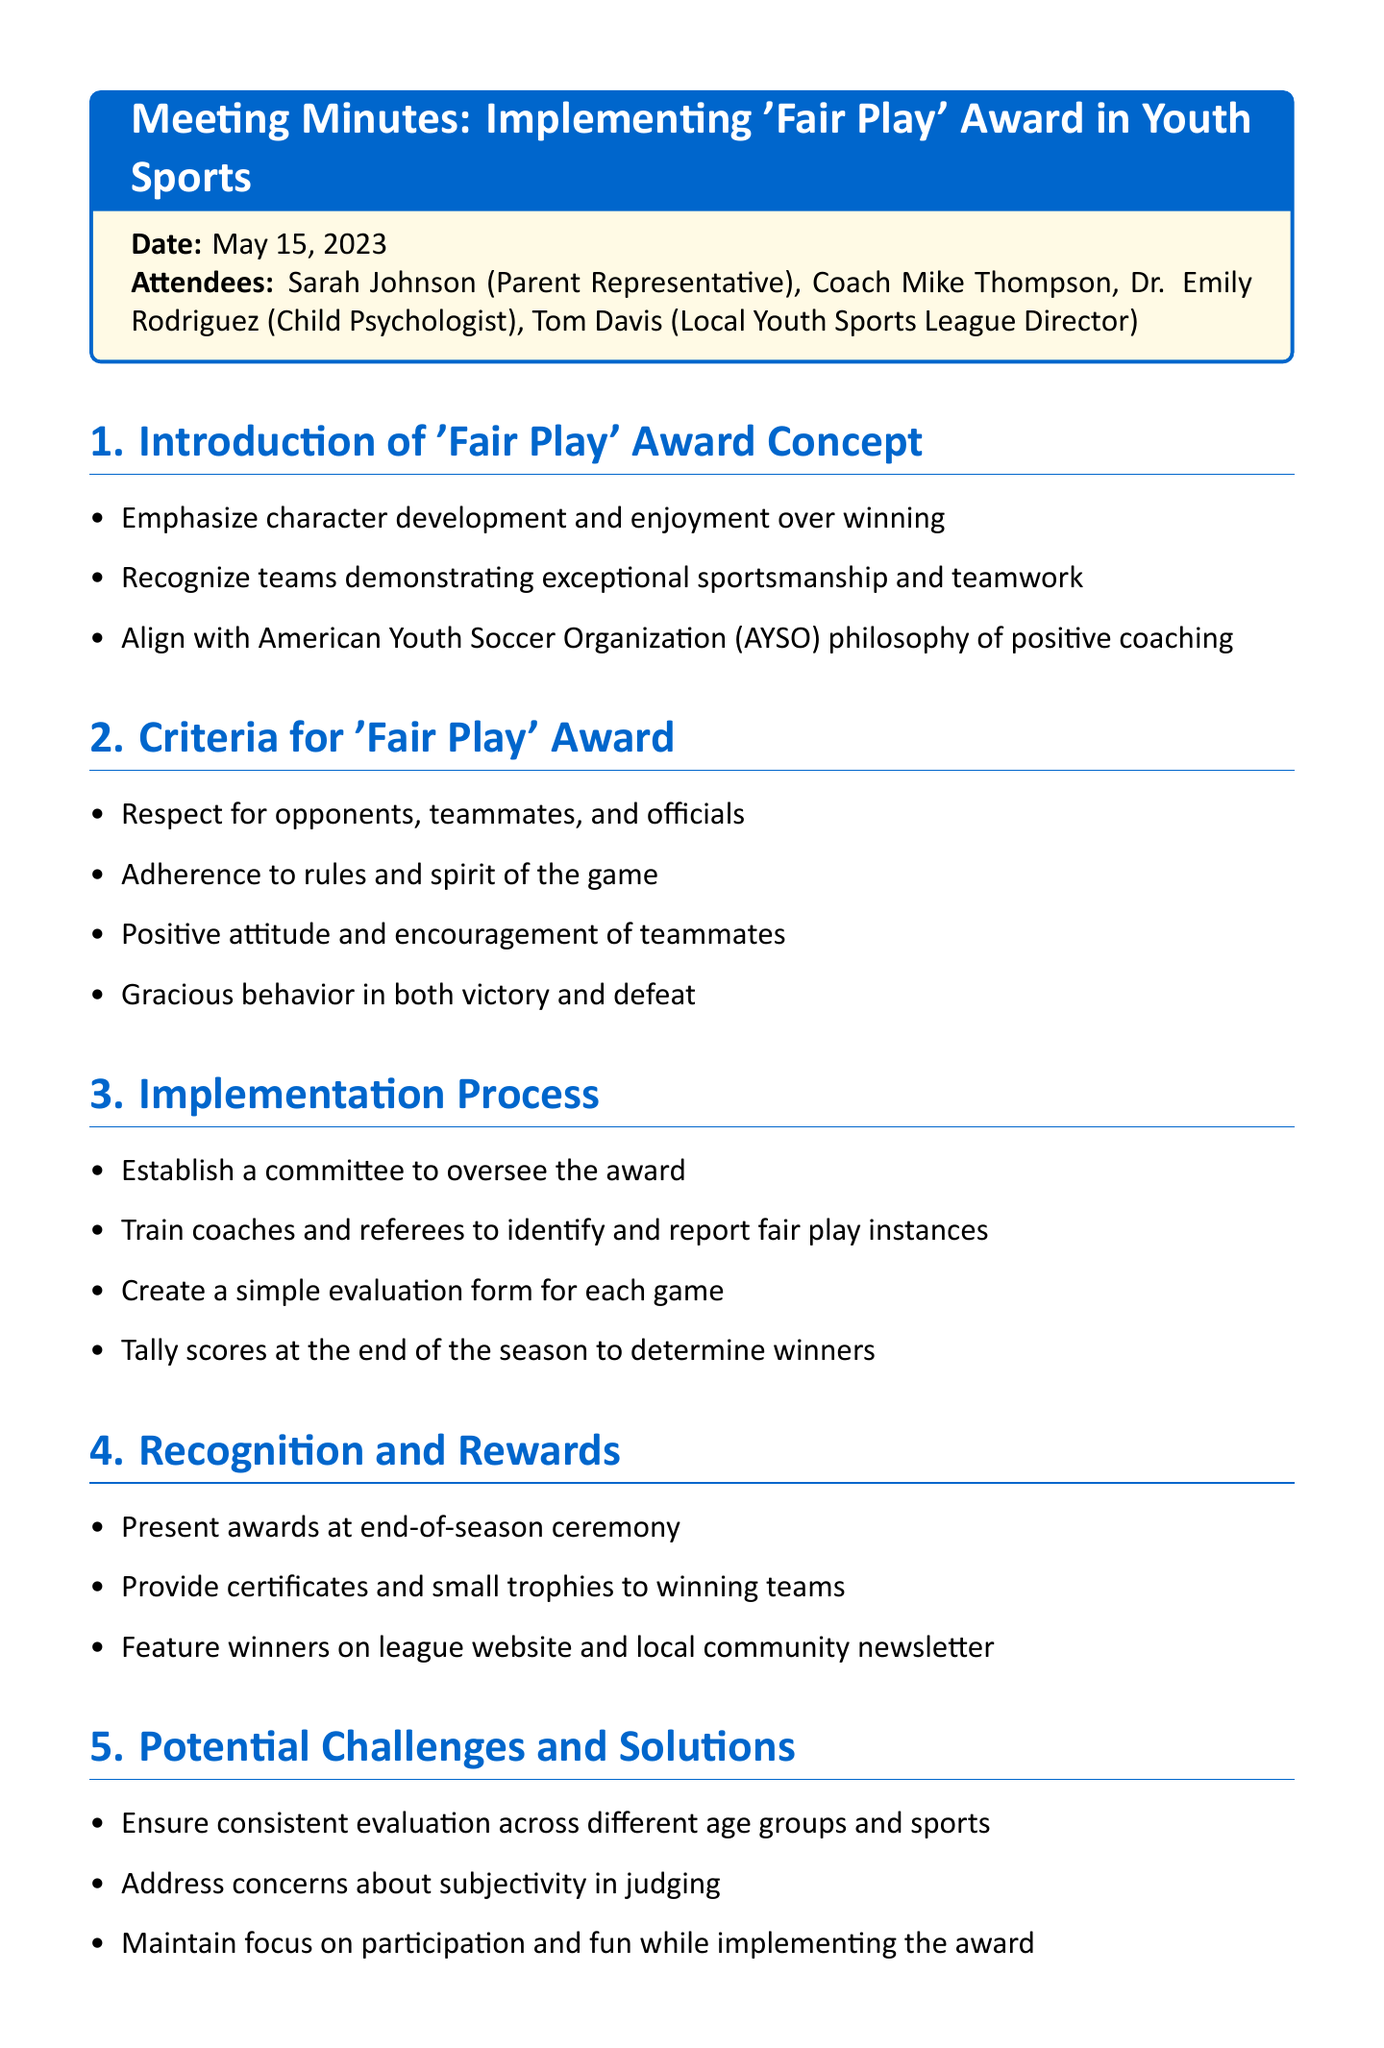What is the date of the meeting? The document specifies the date of the meeting as May 15, 2023.
Answer: May 15, 2023 Who is the parent representative in the meeting? Sarah Johnson is mentioned as the parent representative among the attendees.
Answer: Sarah Johnson What is the first agenda item discussed? The first agenda item addressed is the introduction of the 'Fair Play' award concept.
Answer: Introduction of 'Fair Play' Award Concept What are the criteria for the 'Fair Play' award? The document lists multiple points under the criteria for the award including respect and positive attitude.
Answer: Respect for opponents, teammates, and officials What are the next steps mentioned in the meeting? The document outlines specific next steps including drafting guidelines and presenting proposals.
Answer: Draft official 'Fair Play' award guidelines How will the winners of the 'Fair Play' award be recognized? Recognition and rewards are outlined, detailing that awards will be presented at the end-of-season ceremony.
Answer: Present awards at end-of-season ceremony What potential challenge involves judging? One of the potential challenges discussed is the concern about subjectivity in judging.
Answer: Subjectivity in judging What is a proposed method to observe fair play? The document suggests training coaches and referees to identify fair play instances as a method of observation.
Answer: Train coaches and referees 